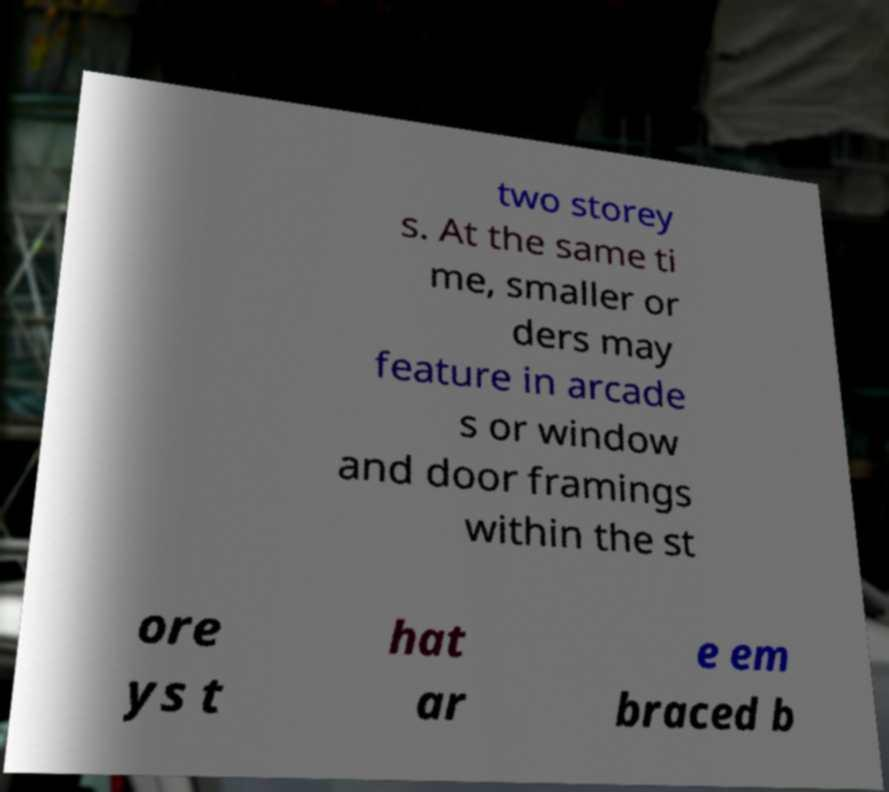What messages or text are displayed in this image? I need them in a readable, typed format. two storey s. At the same ti me, smaller or ders may feature in arcade s or window and door framings within the st ore ys t hat ar e em braced b 